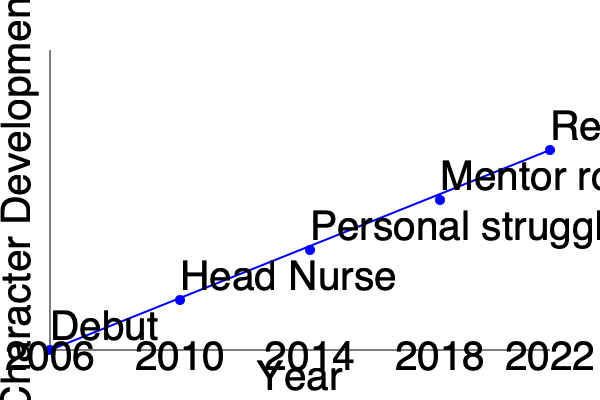Based on the timeline graph of Sonya Eddy's character Epiphany Johnson on General Hospital, which year marked a significant shift in her role, elevating her to a position of authority within the hospital? To answer this question, let's analyze the timeline graph of Sonya Eddy's character progression on General Hospital:

1. The graph shows Epiphany Johnson's character development from 2006 to 2022.
2. Each point on the graph represents a significant change or milestone in her character's journey.
3. The y-axis represents character development, with higher points indicating greater importance or complexity in her role.
4. In 2006, we see her debut on the show.
5. Moving to 2010, we observe a significant jump in her character's position, labeled as "Head Nurse."
6. This shift from her debut to Head Nurse represents a major elevation in her role, giving her a position of authority within the hospital.
7. Subsequent years show further development, but the move to Head Nurse in 2010 stands out as the most significant shift in terms of hospital authority.

Therefore, based on the timeline, 2010 marked the significant shift in Epiphany Johnson's role, elevating her to a position of authority as Head Nurse.
Answer: 2010 